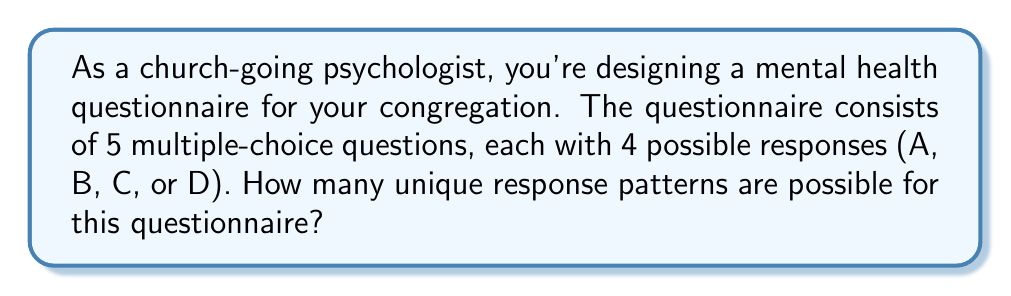Teach me how to tackle this problem. Let's approach this step-by-step:

1) For each question, a respondent has 4 choices (A, B, C, or D).

2) The respondent must make this choice for each of the 5 questions.

3) This scenario is a perfect example of the Multiplication Principle in combinatorics. When we have a series of independent choices, where the number of options for each choice remains constant, we multiply the number of options for each choice.

4) In this case, we have:
   - 4 choices for the 1st question
   - 4 choices for the 2nd question
   - 4 choices for the 3rd question
   - 4 choices for the 4th question
   - 4 choices for the 5th question

5) Mathematically, this can be expressed as:

   $$4 \times 4 \times 4 \times 4 \times 4 = 4^5$$

6) We can calculate this:

   $$4^5 = 4 \times 4 \times 4 \times 4 \times 4 = 1024$$

Therefore, there are 1024 unique response patterns possible for this questionnaire.
Answer: 1024 unique response patterns 